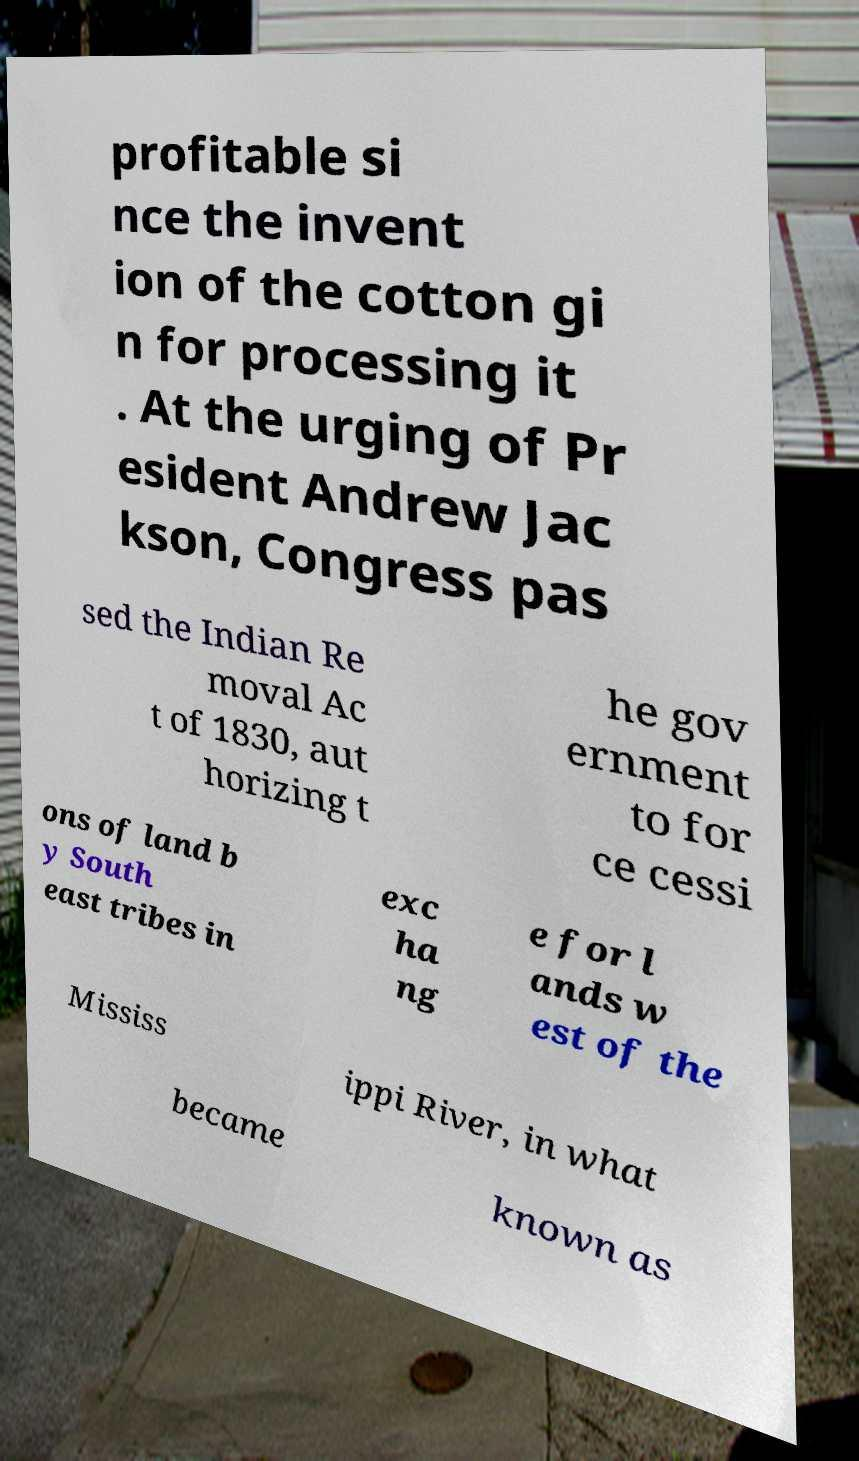There's text embedded in this image that I need extracted. Can you transcribe it verbatim? profitable si nce the invent ion of the cotton gi n for processing it . At the urging of Pr esident Andrew Jac kson, Congress pas sed the Indian Re moval Ac t of 1830, aut horizing t he gov ernment to for ce cessi ons of land b y South east tribes in exc ha ng e for l ands w est of the Mississ ippi River, in what became known as 